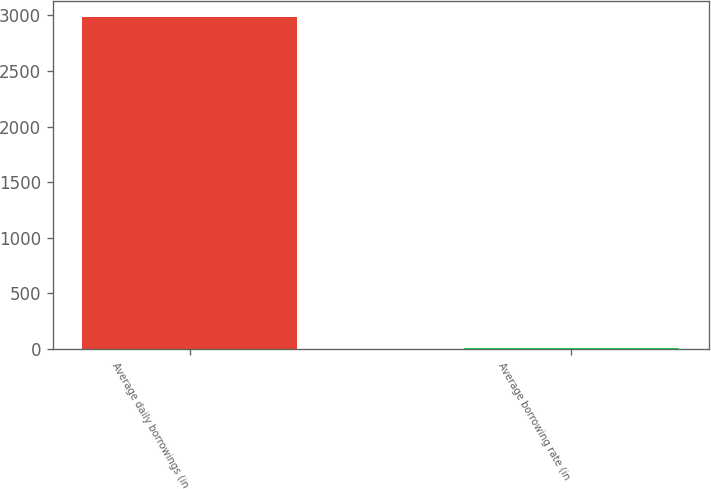Convert chart to OTSL. <chart><loc_0><loc_0><loc_500><loc_500><bar_chart><fcel>Average daily borrowings (in<fcel>Average borrowing rate (in<nl><fcel>2982<fcel>6.7<nl></chart> 